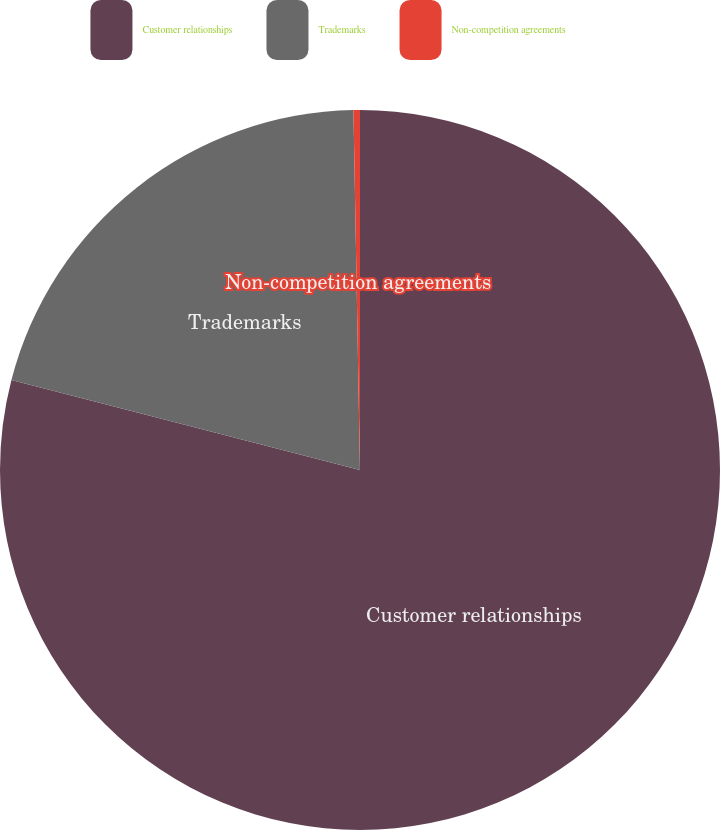Convert chart. <chart><loc_0><loc_0><loc_500><loc_500><pie_chart><fcel>Customer relationships<fcel>Trademarks<fcel>Non-competition agreements<nl><fcel>79.02%<fcel>20.69%<fcel>0.29%<nl></chart> 